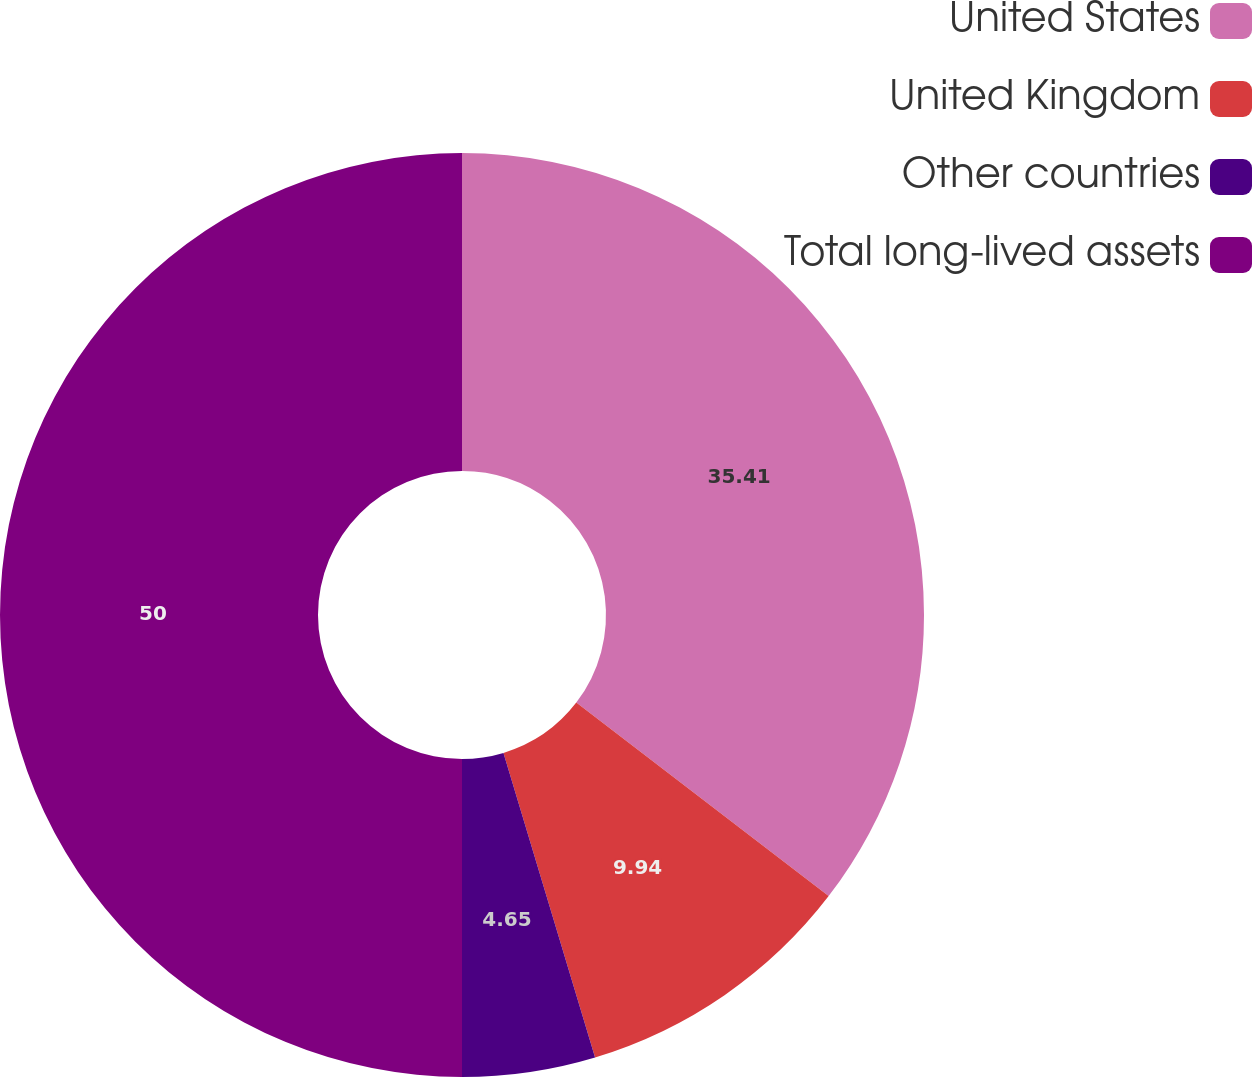Convert chart to OTSL. <chart><loc_0><loc_0><loc_500><loc_500><pie_chart><fcel>United States<fcel>United Kingdom<fcel>Other countries<fcel>Total long-lived assets<nl><fcel>35.41%<fcel>9.94%<fcel>4.65%<fcel>50.0%<nl></chart> 